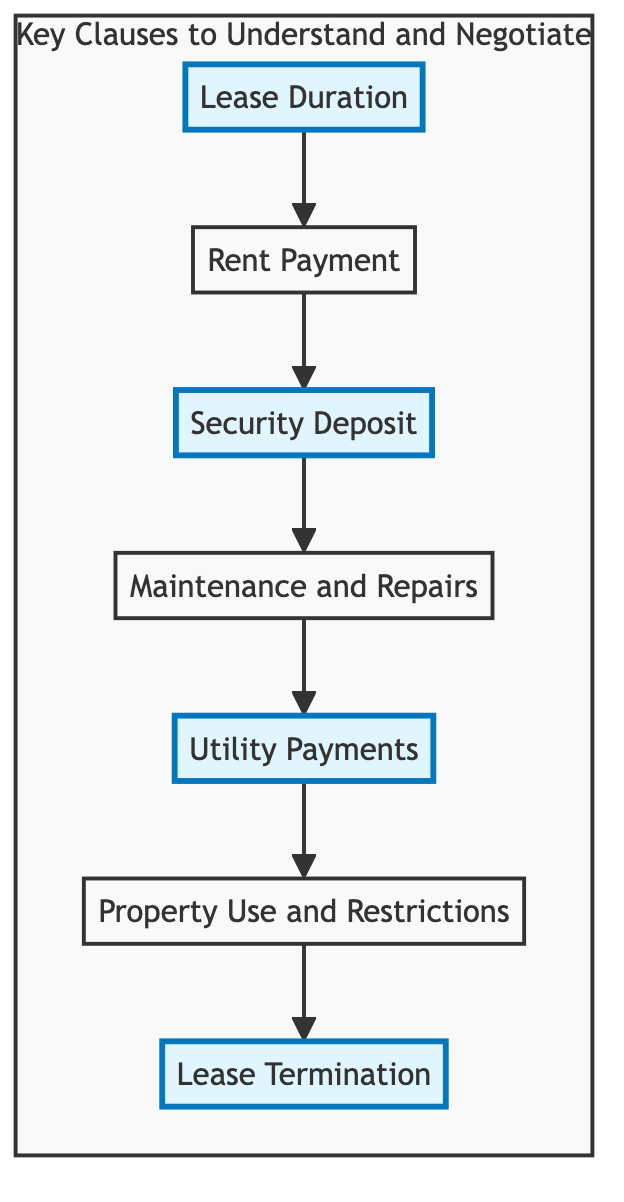What is the first key clause in the flowchart? The first key clause in the flowchart is "Lease Duration," which is the initial node that the flow starts with.
Answer: Lease Duration How many key clauses are there in total? The flowchart contains seven key clauses, each representing a crucial aspect of the lease agreement.
Answer: Seven What comes after Security Deposit in the flowchart? After the "Security Deposit" node, the next clause in the flowchart is "Maintenance and Repairs," indicating the flow of evaluation among the clauses.
Answer: Maintenance and Repairs Which clauses are highlighted in the flowchart? The highlighted clauses in the flowchart are "Lease Duration," "Security Deposit," "Utility Payments," and "Lease Termination," indicating their significance or areas to pay special attention to.
Answer: Lease Duration, Security Deposit, Utility Payments, Lease Termination What is the relationship between Rent Payment and Utility Payments? "Utility Payments" follows "Rent Payment," providing a sequential relationship where the tenant evaluates both rent obligations and utility responsibilities as part of the lease agreement assessment.
Answer: Sequential relationship How does the flowchart visually categorize important clauses? The flowchart uses a highlighted style for significant clauses, distinguishing them from the rest by changing their background color, focusing attention on those areas during evaluation.
Answer: Highlighted style What is the last key clause in the flowchart? The last key clause in the flowchart is "Lease Termination," which concludes the sequence of evaluation among the various clauses.
Answer: Lease Termination 